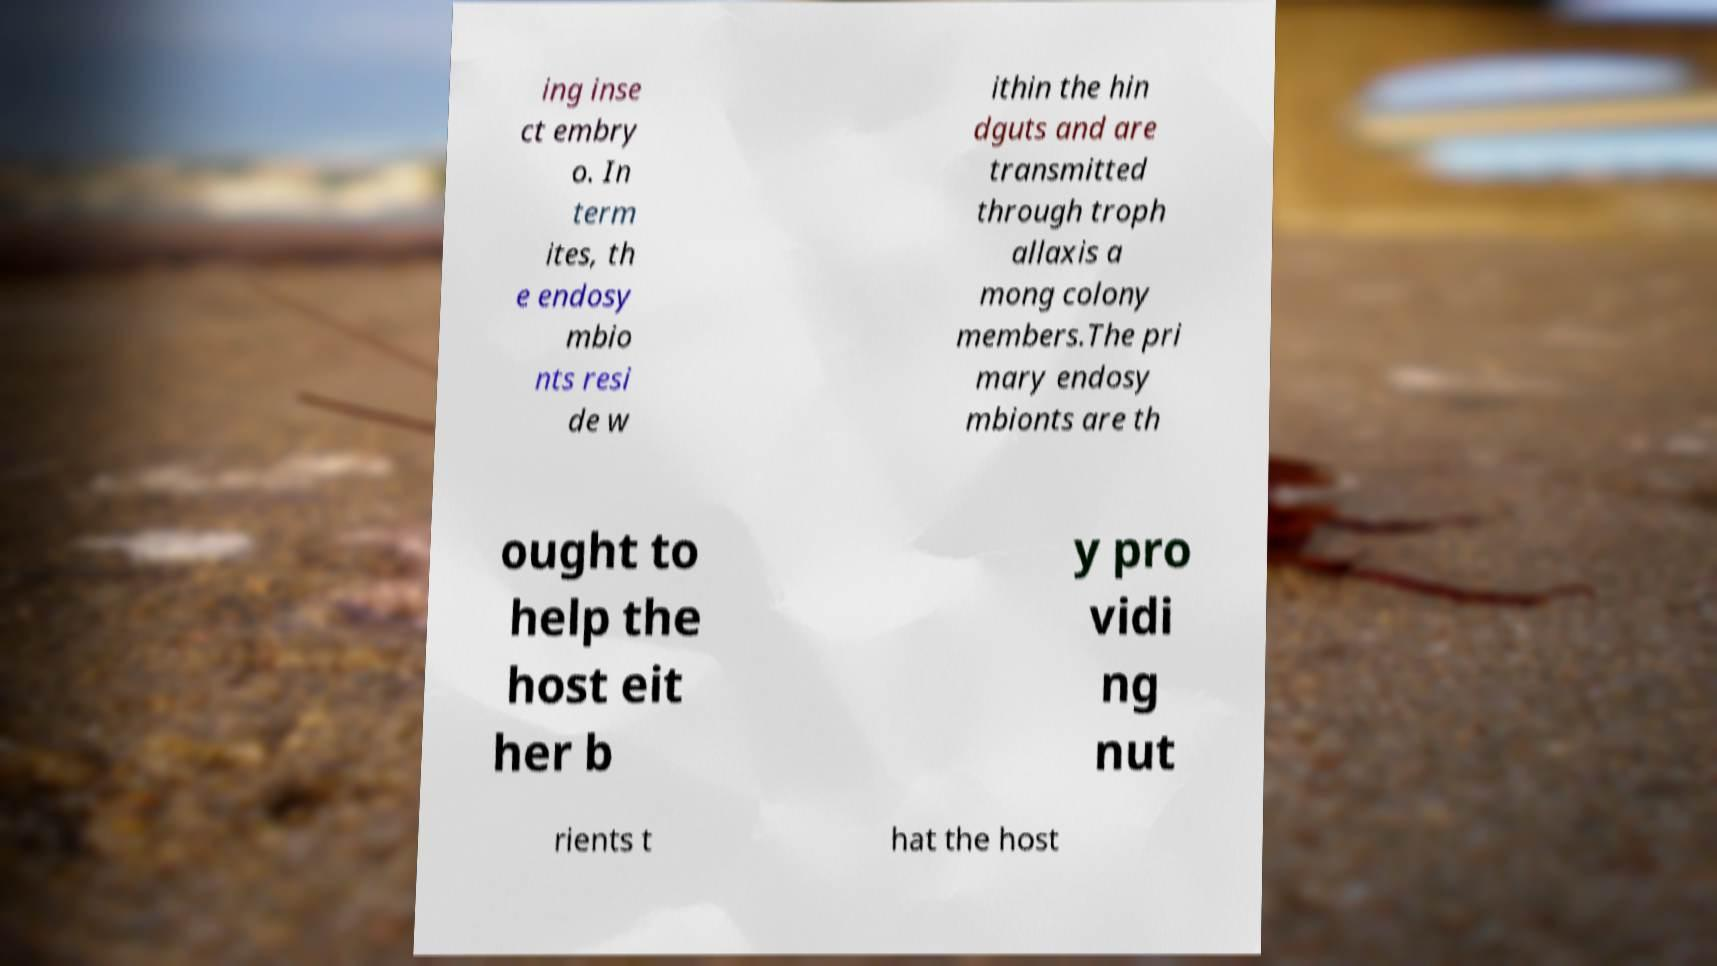Could you assist in decoding the text presented in this image and type it out clearly? ing inse ct embry o. In term ites, th e endosy mbio nts resi de w ithin the hin dguts and are transmitted through troph allaxis a mong colony members.The pri mary endosy mbionts are th ought to help the host eit her b y pro vidi ng nut rients t hat the host 